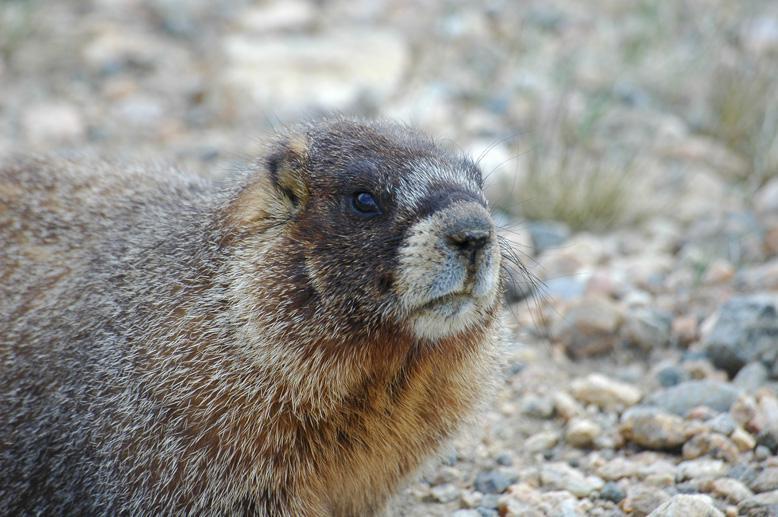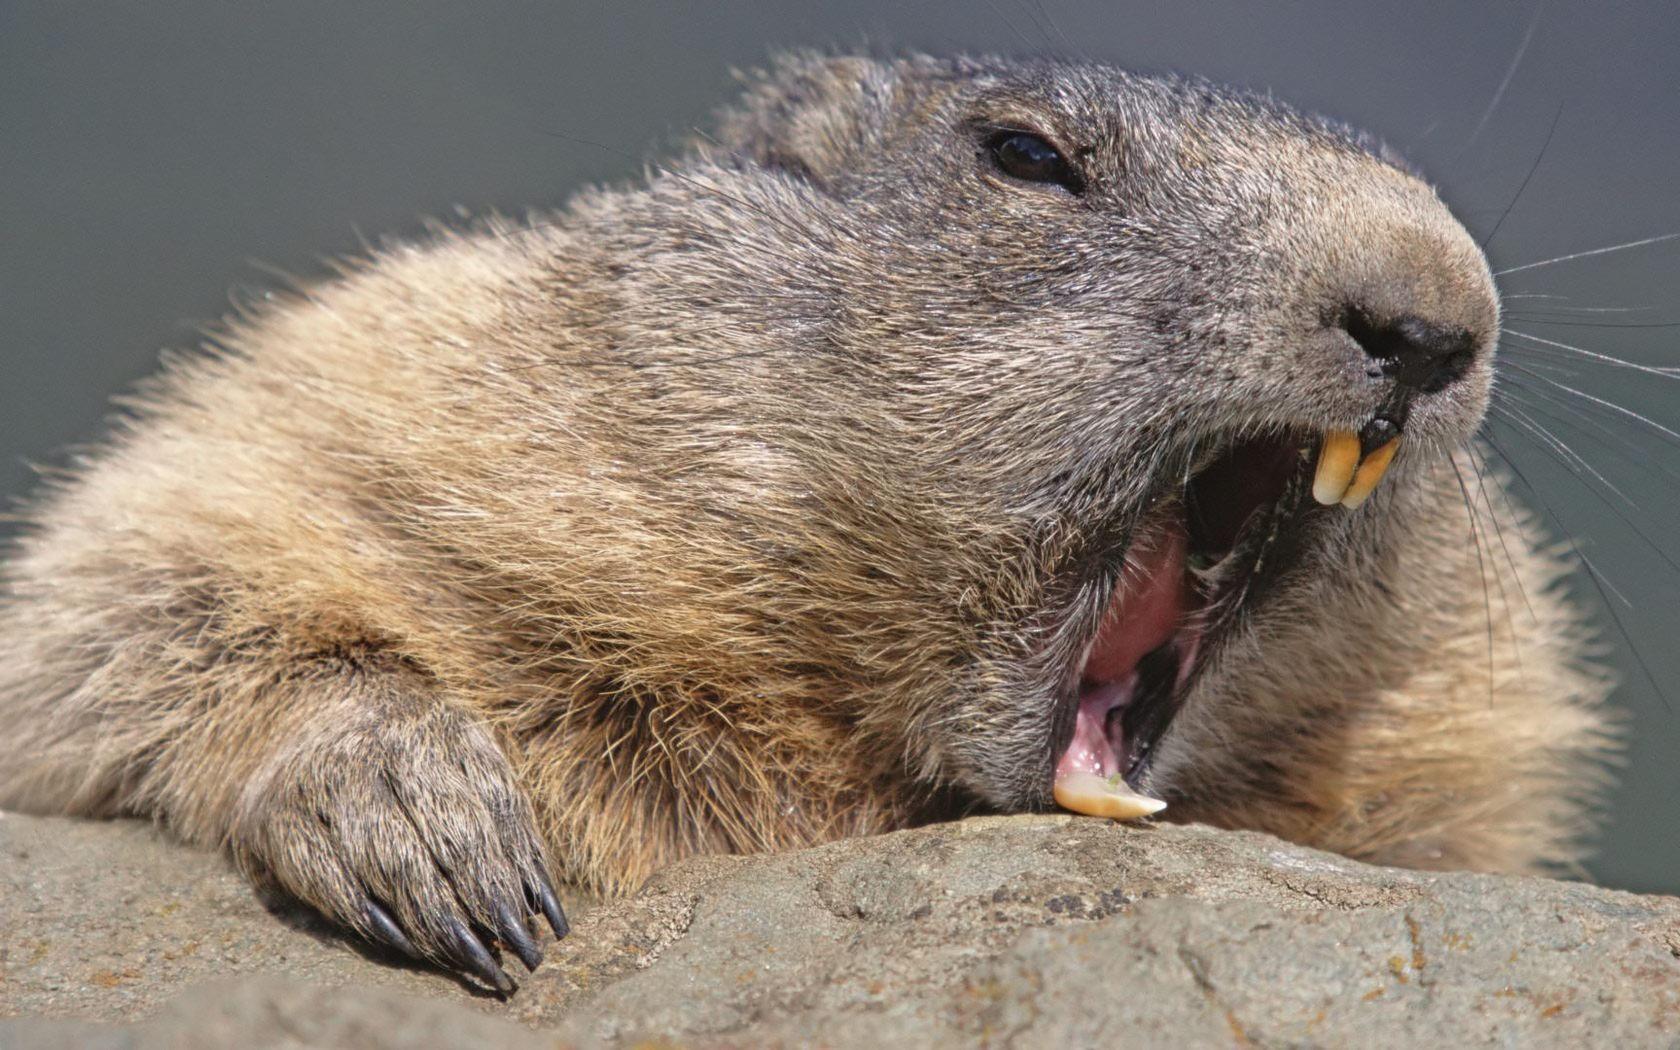The first image is the image on the left, the second image is the image on the right. Evaluate the accuracy of this statement regarding the images: "The animals in both images face approximately the same direction.". Is it true? Answer yes or no. Yes. 